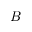<formula> <loc_0><loc_0><loc_500><loc_500>B</formula> 